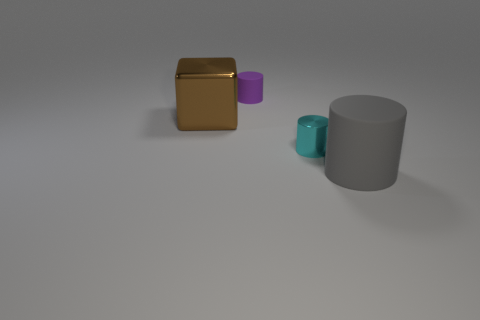Subtract 1 cylinders. How many cylinders are left? 2 Add 3 shiny objects. How many objects exist? 7 Subtract all cylinders. How many objects are left? 1 Subtract all big yellow things. Subtract all big objects. How many objects are left? 2 Add 4 purple cylinders. How many purple cylinders are left? 5 Add 1 tiny rubber things. How many tiny rubber things exist? 2 Subtract 0 yellow spheres. How many objects are left? 4 